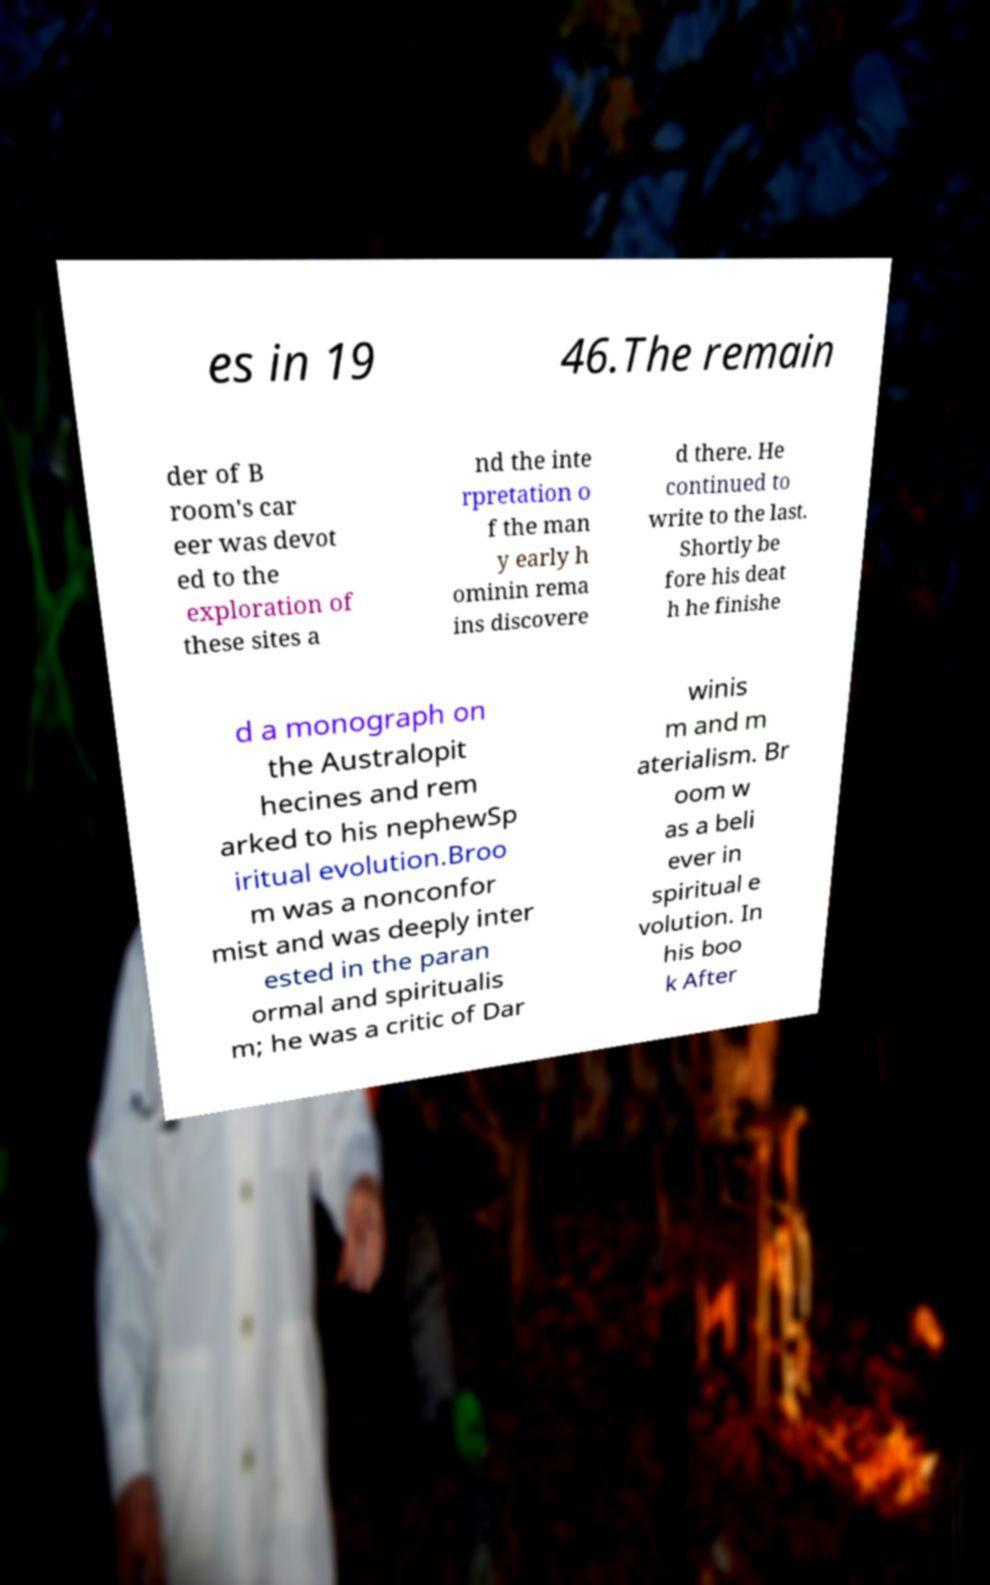Can you read and provide the text displayed in the image?This photo seems to have some interesting text. Can you extract and type it out for me? es in 19 46.The remain der of B room's car eer was devot ed to the exploration of these sites a nd the inte rpretation o f the man y early h ominin rema ins discovere d there. He continued to write to the last. Shortly be fore his deat h he finishe d a monograph on the Australopit hecines and rem arked to his nephewSp iritual evolution.Broo m was a nonconfor mist and was deeply inter ested in the paran ormal and spiritualis m; he was a critic of Dar winis m and m aterialism. Br oom w as a beli ever in spiritual e volution. In his boo k After 